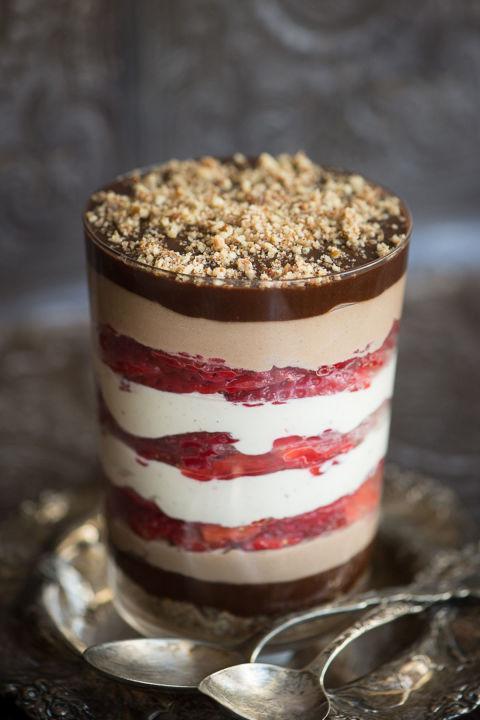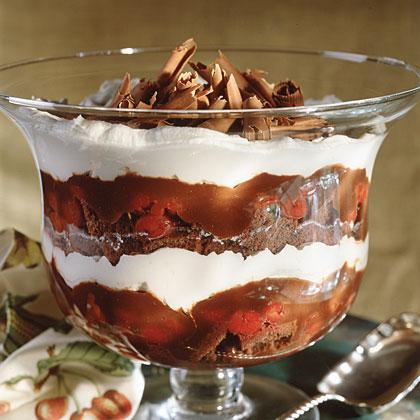The first image is the image on the left, the second image is the image on the right. Examine the images to the left and right. Is the description "A spoon is sitting on the left of the dessert bowls in at least one of the images." accurate? Answer yes or no. No. 